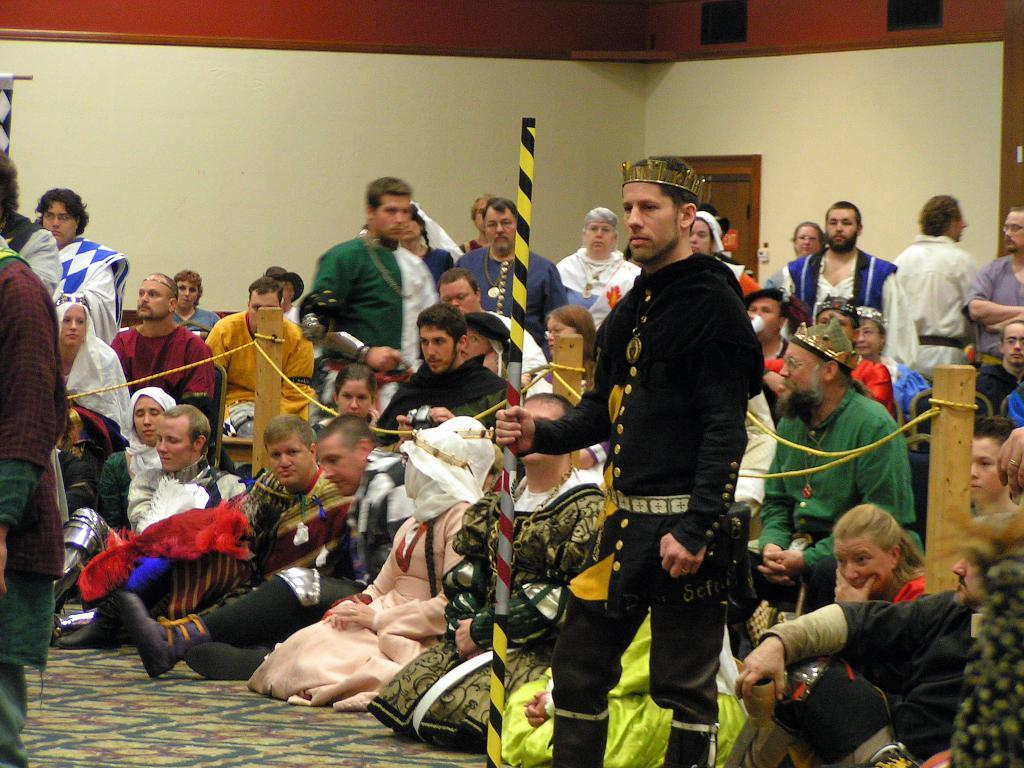How many people are in the image? There is a group of people in the image. What are the people wearing? The people are wearing different color costumes. What can be seen in the background of the image? There is a wall in the image. What object is a person holding in the image? A person is holding a stick in the image. What type of hose is being used by the person in the image? There is no hose present in the image; a person is holding a stick instead. 